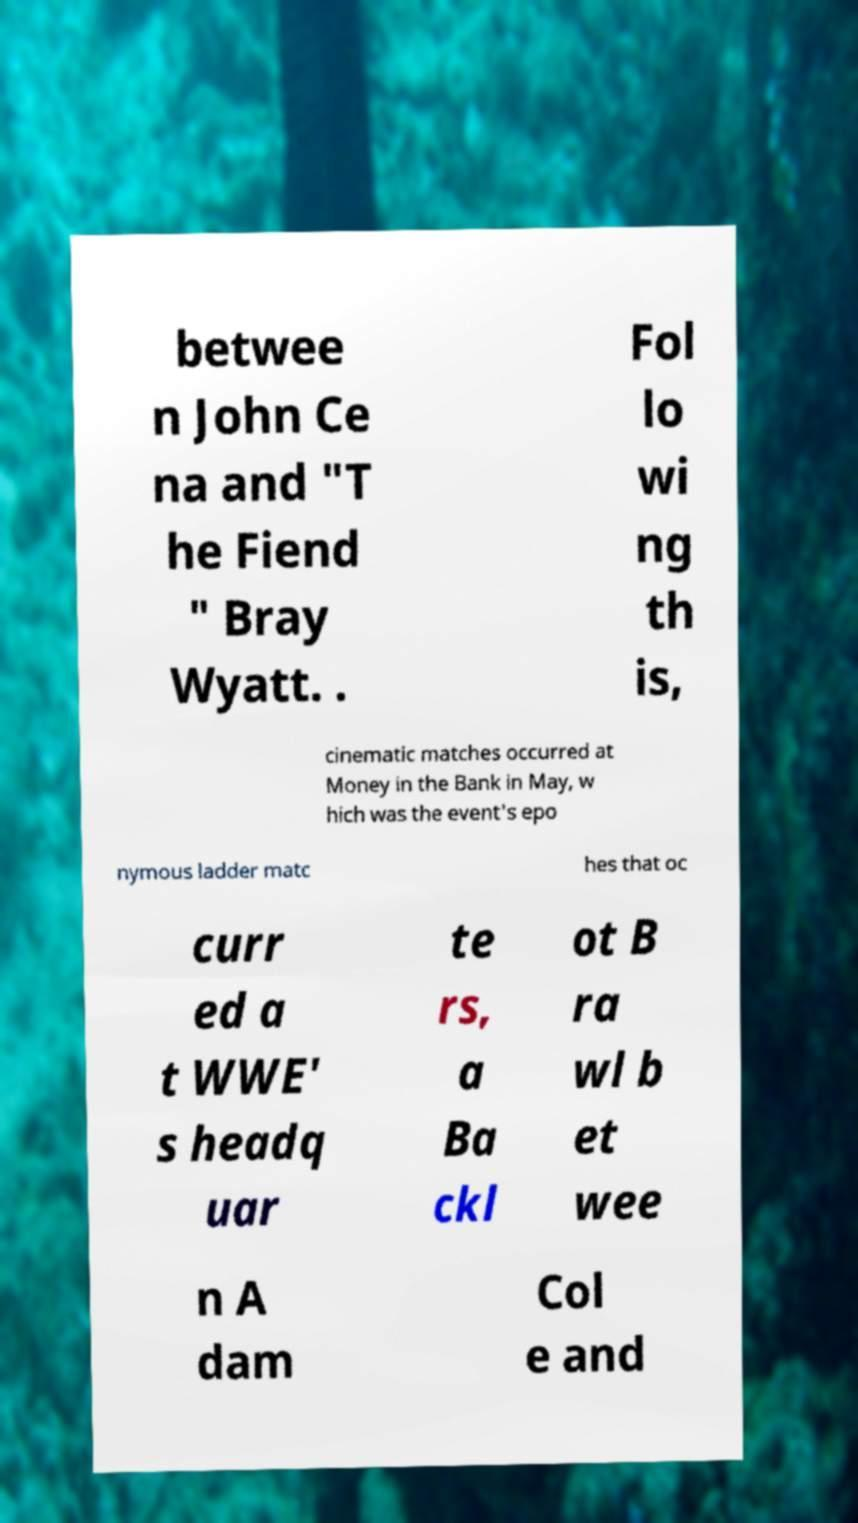Please identify and transcribe the text found in this image. betwee n John Ce na and "T he Fiend " Bray Wyatt. . Fol lo wi ng th is, cinematic matches occurred at Money in the Bank in May, w hich was the event's epo nymous ladder matc hes that oc curr ed a t WWE' s headq uar te rs, a Ba ckl ot B ra wl b et wee n A dam Col e and 